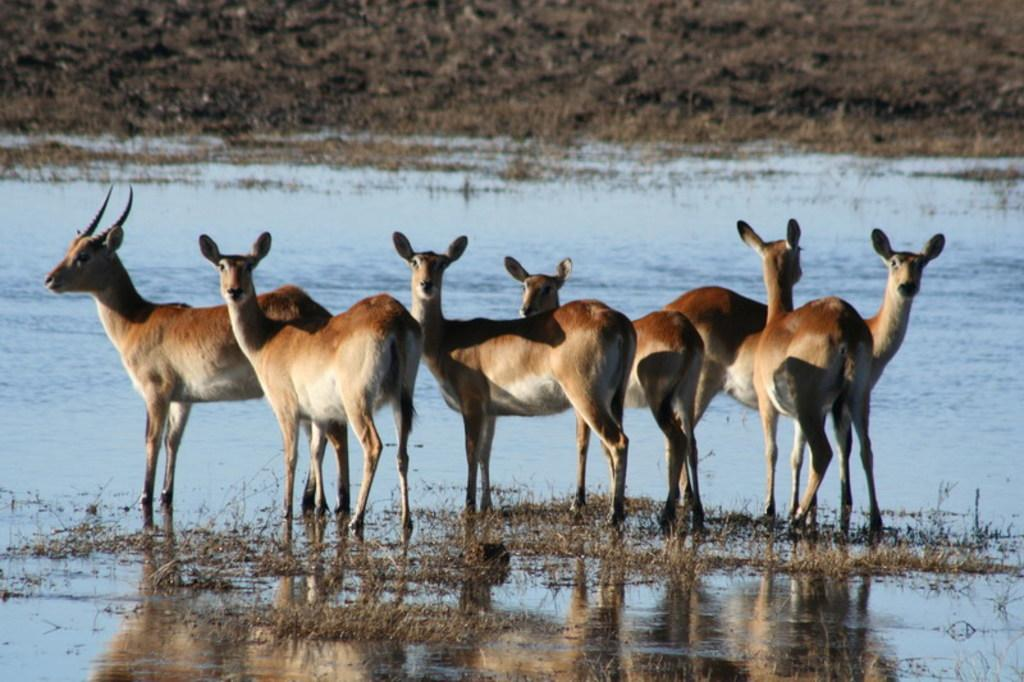What type of animals can be seen in the image? There are animals in the river in the image. Can you describe the setting where the animals are located? The animals are in a river, which suggests a natural environment. What might the animals be doing in the river? The animals might be swimming, drinking, or searching for food in the river. What type of theory can be seen being tested by the animals in the image? There is no theory present in the image; it features animals in a river. 